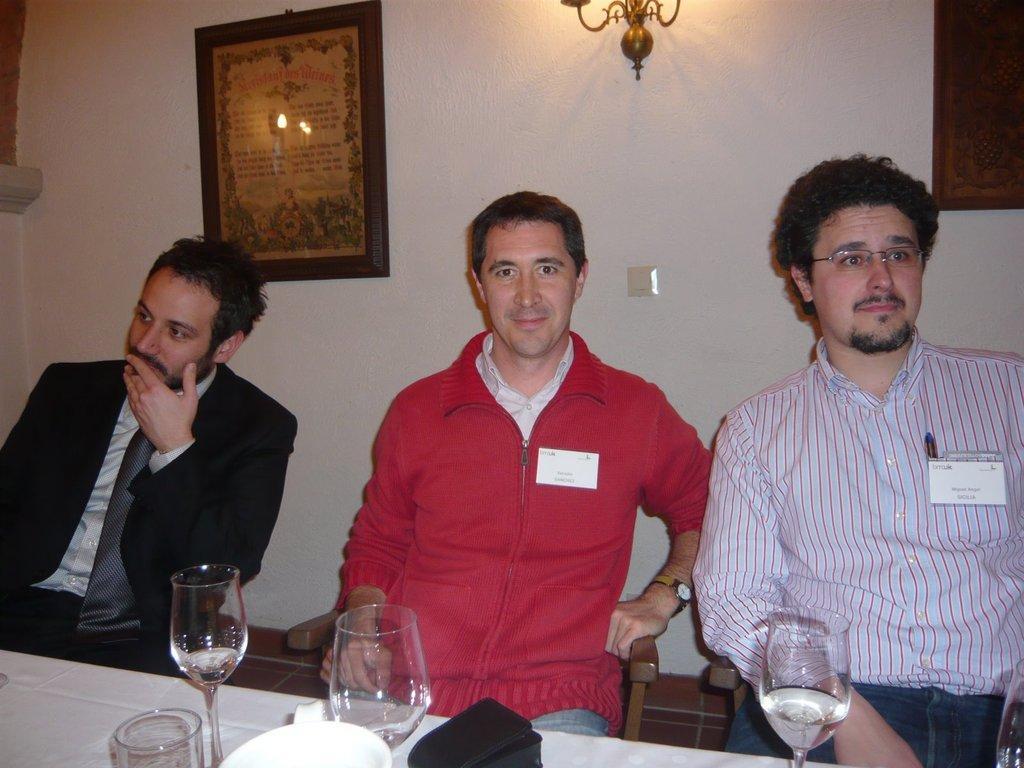How would you summarize this image in a sentence or two? The picture is taken inside a room. There are three persons in the room. the right person is wearing a white shirt,the middle person is wearing a red jacket,the left person is wearing a black suit. In front of them there is a table. On the table there is glasses,plate. There is a wall behind them. on the wall there is a board and a light. 